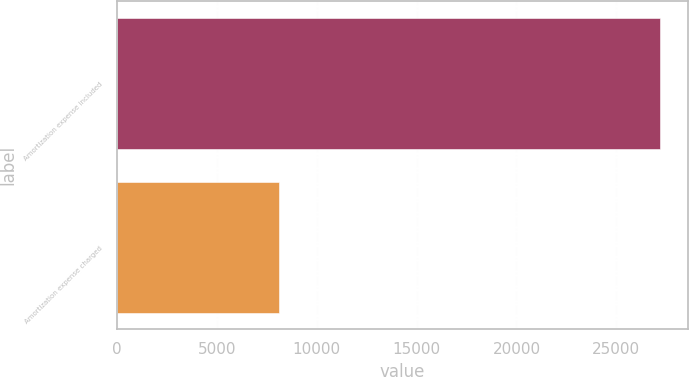Convert chart. <chart><loc_0><loc_0><loc_500><loc_500><bar_chart><fcel>Amortization expense included<fcel>Amortization expense charged<nl><fcel>27202<fcel>8096<nl></chart> 